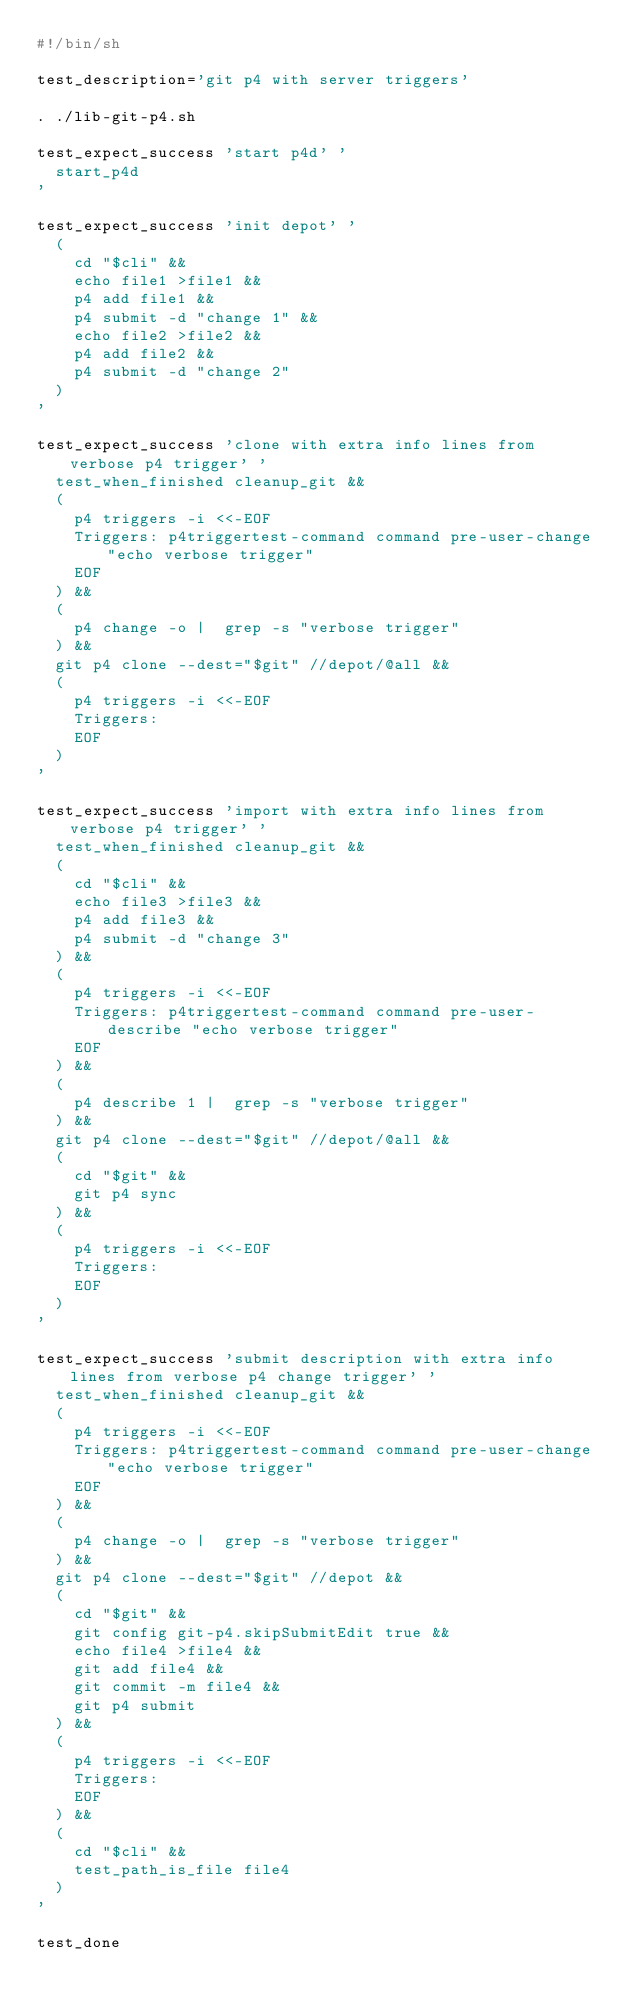Convert code to text. <code><loc_0><loc_0><loc_500><loc_500><_Bash_>#!/bin/sh

test_description='git p4 with server triggers'

. ./lib-git-p4.sh

test_expect_success 'start p4d' '
	start_p4d
'

test_expect_success 'init depot' '
	(
		cd "$cli" &&
		echo file1 >file1 &&
		p4 add file1 &&
		p4 submit -d "change 1" &&
		echo file2 >file2 &&
		p4 add file2 &&
		p4 submit -d "change 2"
	)
'

test_expect_success 'clone with extra info lines from verbose p4 trigger' '
	test_when_finished cleanup_git &&
	(
		p4 triggers -i <<-EOF
		Triggers: p4triggertest-command command pre-user-change "echo verbose trigger"
		EOF
	) &&
	(
		p4 change -o |  grep -s "verbose trigger"
	) &&
	git p4 clone --dest="$git" //depot/@all &&
	(
		p4 triggers -i <<-EOF
		Triggers:
		EOF
	)
'

test_expect_success 'import with extra info lines from verbose p4 trigger' '
	test_when_finished cleanup_git &&
	(
		cd "$cli" &&
		echo file3 >file3 &&
		p4 add file3 &&
		p4 submit -d "change 3"
	) &&
	(
		p4 triggers -i <<-EOF
		Triggers: p4triggertest-command command pre-user-describe "echo verbose trigger"
		EOF
	) &&
	(
		p4 describe 1 |  grep -s "verbose trigger"
	) &&
	git p4 clone --dest="$git" //depot/@all &&
	(
		cd "$git" &&
		git p4 sync
	) &&
	(
		p4 triggers -i <<-EOF
		Triggers:
		EOF
	)
'

test_expect_success 'submit description with extra info lines from verbose p4 change trigger' '
	test_when_finished cleanup_git &&
	(
		p4 triggers -i <<-EOF
		Triggers: p4triggertest-command command pre-user-change "echo verbose trigger"
		EOF
	) &&
	(
		p4 change -o |  grep -s "verbose trigger"
	) &&
	git p4 clone --dest="$git" //depot &&
	(
		cd "$git" &&
		git config git-p4.skipSubmitEdit true &&
		echo file4 >file4 &&
		git add file4 &&
		git commit -m file4 &&
		git p4 submit
	) &&
	(
		p4 triggers -i <<-EOF
		Triggers:
		EOF
	) &&
	(
		cd "$cli" &&
		test_path_is_file file4
	)
'

test_done
</code> 